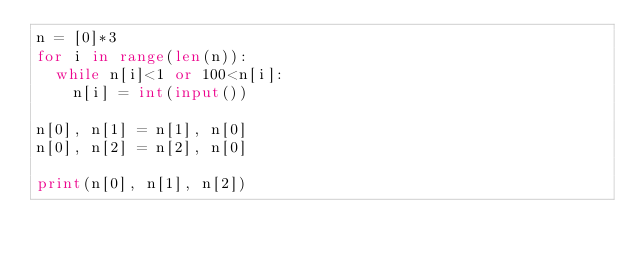<code> <loc_0><loc_0><loc_500><loc_500><_Python_>n = [0]*3
for i in range(len(n)):
  while n[i]<1 or 100<n[i]:
    n[i] = int(input())

n[0], n[1] = n[1], n[0]
n[0], n[2] = n[2], n[0]

print(n[0], n[1], n[2])</code> 